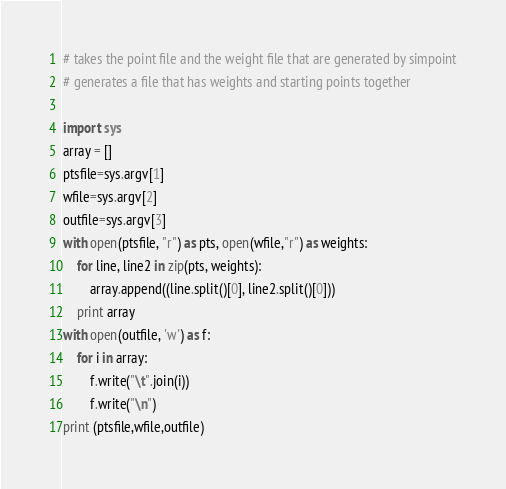Convert code to text. <code><loc_0><loc_0><loc_500><loc_500><_Python_># takes the point file and the weight file that are generated by simpoint
# generates a file that has weights and starting points together

import sys
array = []
ptsfile=sys.argv[1]
wfile=sys.argv[2]
outfile=sys.argv[3]
with open(ptsfile, "r") as pts, open(wfile,"r") as weights:
    for line, line2 in zip(pts, weights):
        array.append((line.split()[0], line2.split()[0]))
    print array
with open(outfile, 'w') as f:
    for i in array:
        f.write("\t".join(i))
        f.write("\n")
print (ptsfile,wfile,outfile)
</code> 